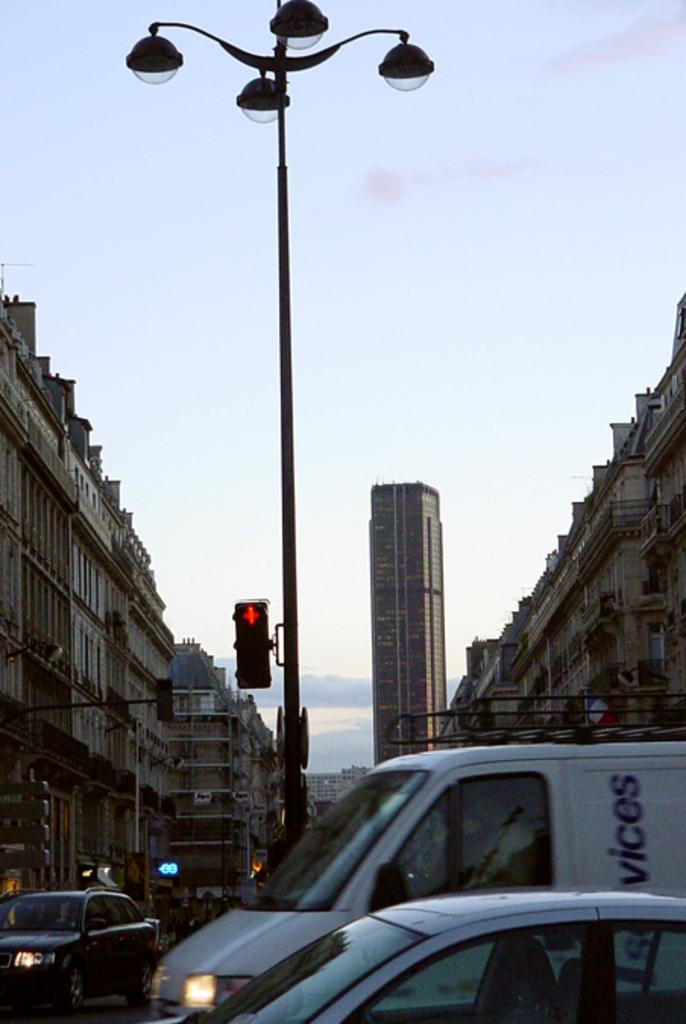What types of objects are at the bottom of the image? There are vehicles at the bottom of the image. What can be seen in the distance in the image? There are buildings, light poles, traffic signal poles, and small boards in the background of the image. What is visible in the sky in the background of the image? Clouds are visible in the sky in the background of the image. Where is the pump located in the image? There is no pump present in the image. What type of hose is being used by the buildings in the image? There is no hose visible in the image; only buildings, light poles, traffic signal poles, and small boards are present in the background. 